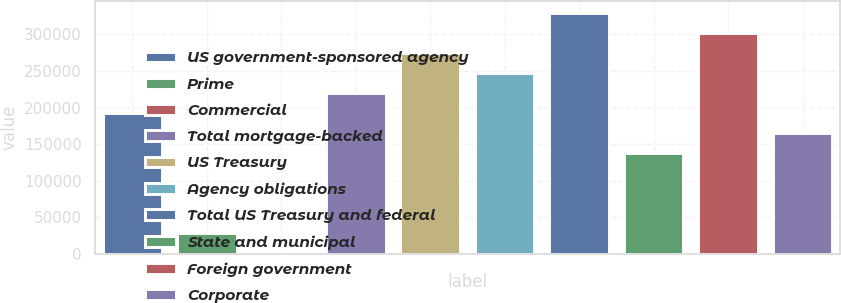Convert chart to OTSL. <chart><loc_0><loc_0><loc_500><loc_500><bar_chart><fcel>US government-sponsored agency<fcel>Prime<fcel>Commercial<fcel>Total mortgage-backed<fcel>US Treasury<fcel>Agency obligations<fcel>Total US Treasury and federal<fcel>State and municipal<fcel>Foreign government<fcel>Corporate<nl><fcel>192373<fcel>27973.8<fcel>574<fcel>219772<fcel>274572<fcel>247172<fcel>329372<fcel>137573<fcel>301972<fcel>164973<nl></chart> 